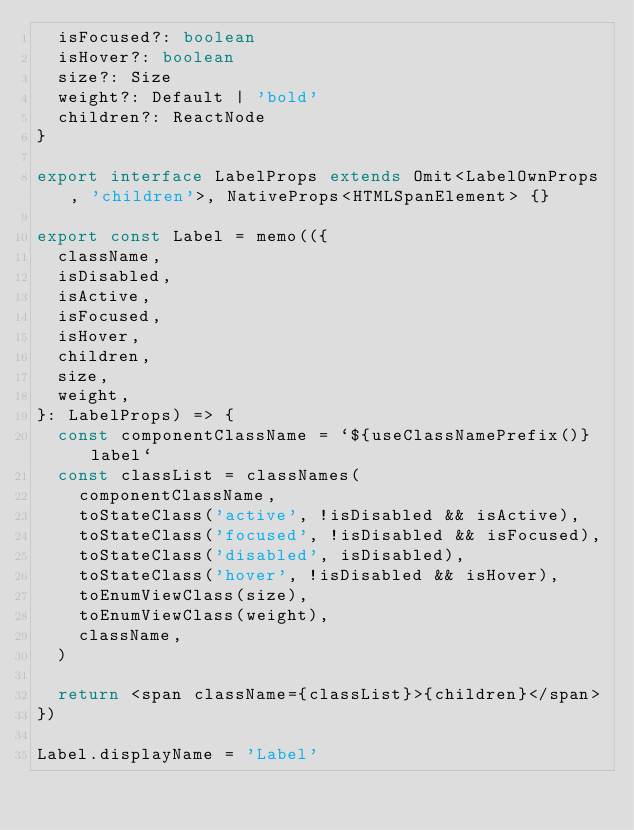<code> <loc_0><loc_0><loc_500><loc_500><_TypeScript_>  isFocused?: boolean
  isHover?: boolean
  size?: Size
  weight?: Default | 'bold'
  children?: ReactNode
}

export interface LabelProps extends Omit<LabelOwnProps, 'children'>, NativeProps<HTMLSpanElement> {}

export const Label = memo(({
  className,
  isDisabled,
  isActive,
  isFocused,
  isHover,
  children,
  size,
  weight,
}: LabelProps) => {
  const componentClassName = `${useClassNamePrefix()}label`
  const classList = classNames(
    componentClassName,
    toStateClass('active', !isDisabled && isActive),
    toStateClass('focused', !isDisabled && isFocused),
    toStateClass('disabled', isDisabled),
    toStateClass('hover', !isDisabled && isHover),
    toEnumViewClass(size),
    toEnumViewClass(weight),
    className,
  )

  return <span className={classList}>{children}</span>
})

Label.displayName = 'Label'
</code> 